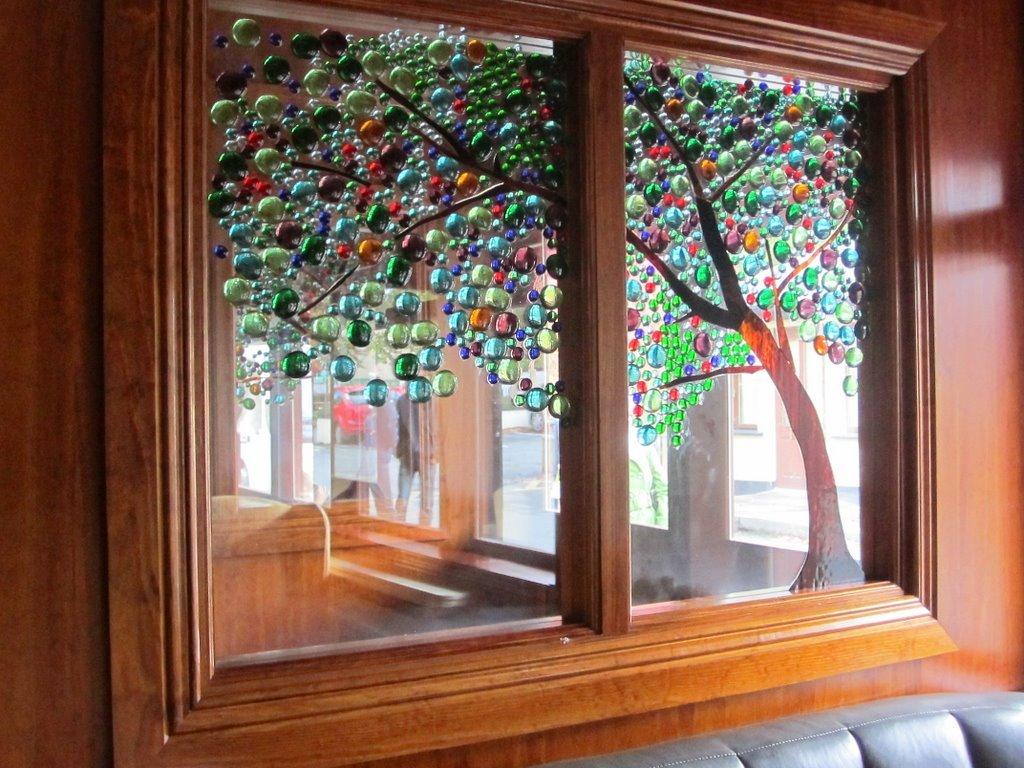What is the main feature in the center of the image? There is a window in the center of the image. What can be seen through the window? There are persons behind the window. What decorative element is present on the window glasses? There is a design of a tree on the window glasses. Reasoning: Let's think step by step by step in order to produce the conversation. We start by identifying the main subject of the image, which is the window. Then, we describe what can be seen through the window, which are the persons. Finally, we mention the decorative element on the window glasses, which is the tree design. Each question is designed to elicit a specific detail about the image that is known from the provided facts. Absurd Question/Answer: What type of honey is being served to the queen in the image? There is no queen or honey present in the image; it only features a window with a tree design on the glasses and persons behind the window. 